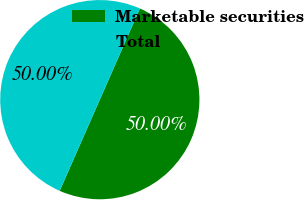<chart> <loc_0><loc_0><loc_500><loc_500><pie_chart><fcel>Marketable securities<fcel>Total<nl><fcel>50.0%<fcel>50.0%<nl></chart> 